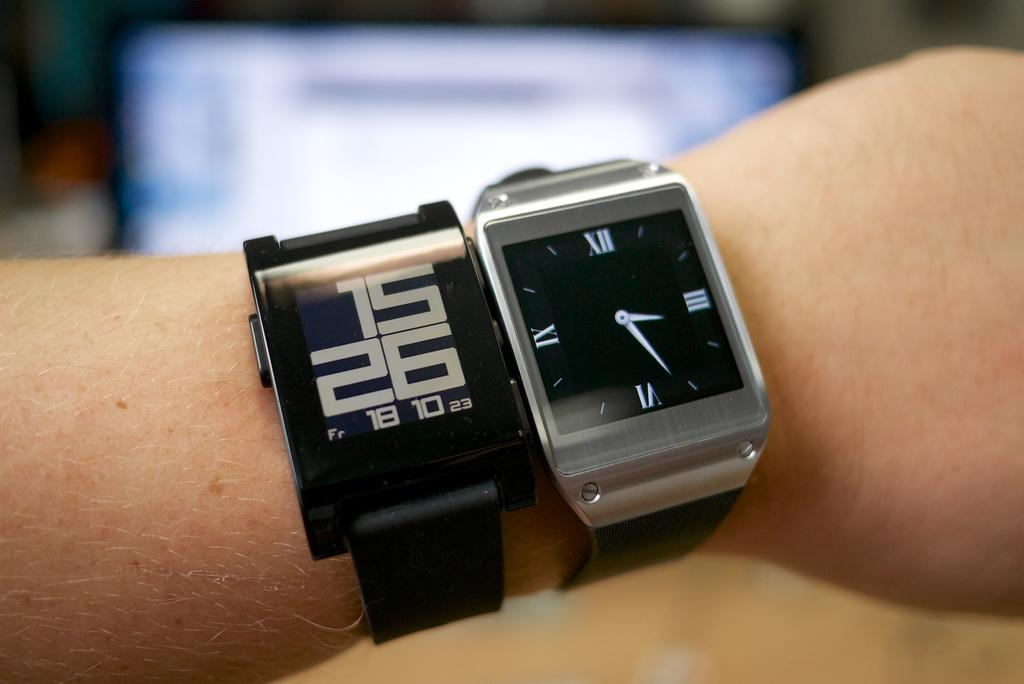<image>
Summarize the visual content of the image. A person wears two watches with both displaying the time of 3:26. 